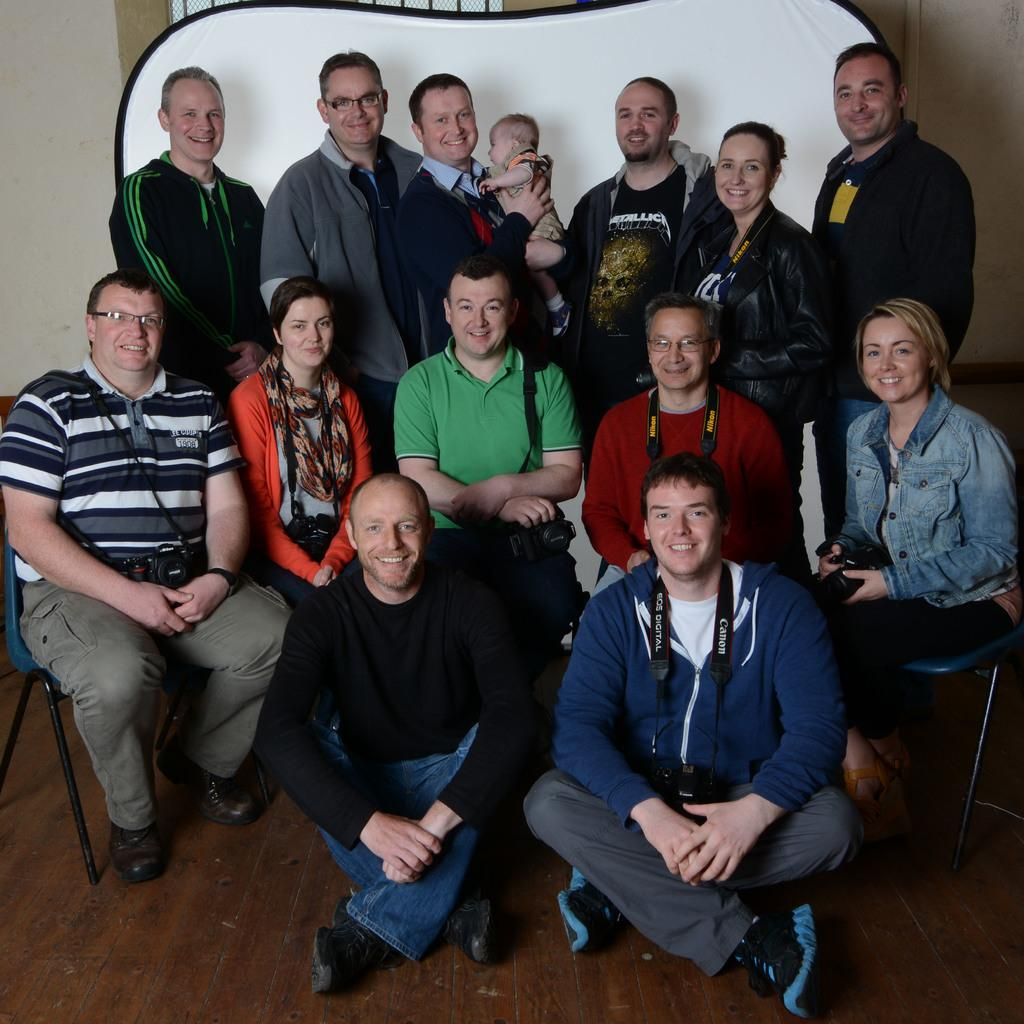What are the people in the image doing? The people in the image are sitting and standing. What is the mood of the people in the image? The people in the image are smiling, which suggests a positive mood. What is the surface beneath the people in the image? There is a floor visible in the image. What can be seen in the background of the image? There is a wall in the background of the image. How many locks can be seen on the wall in the image? There are no locks visible on the wall in the image. Are the people in the image sisters? The provided facts do not mention any familial relationships between the people in the image, so we cannot determine if they are sisters. 